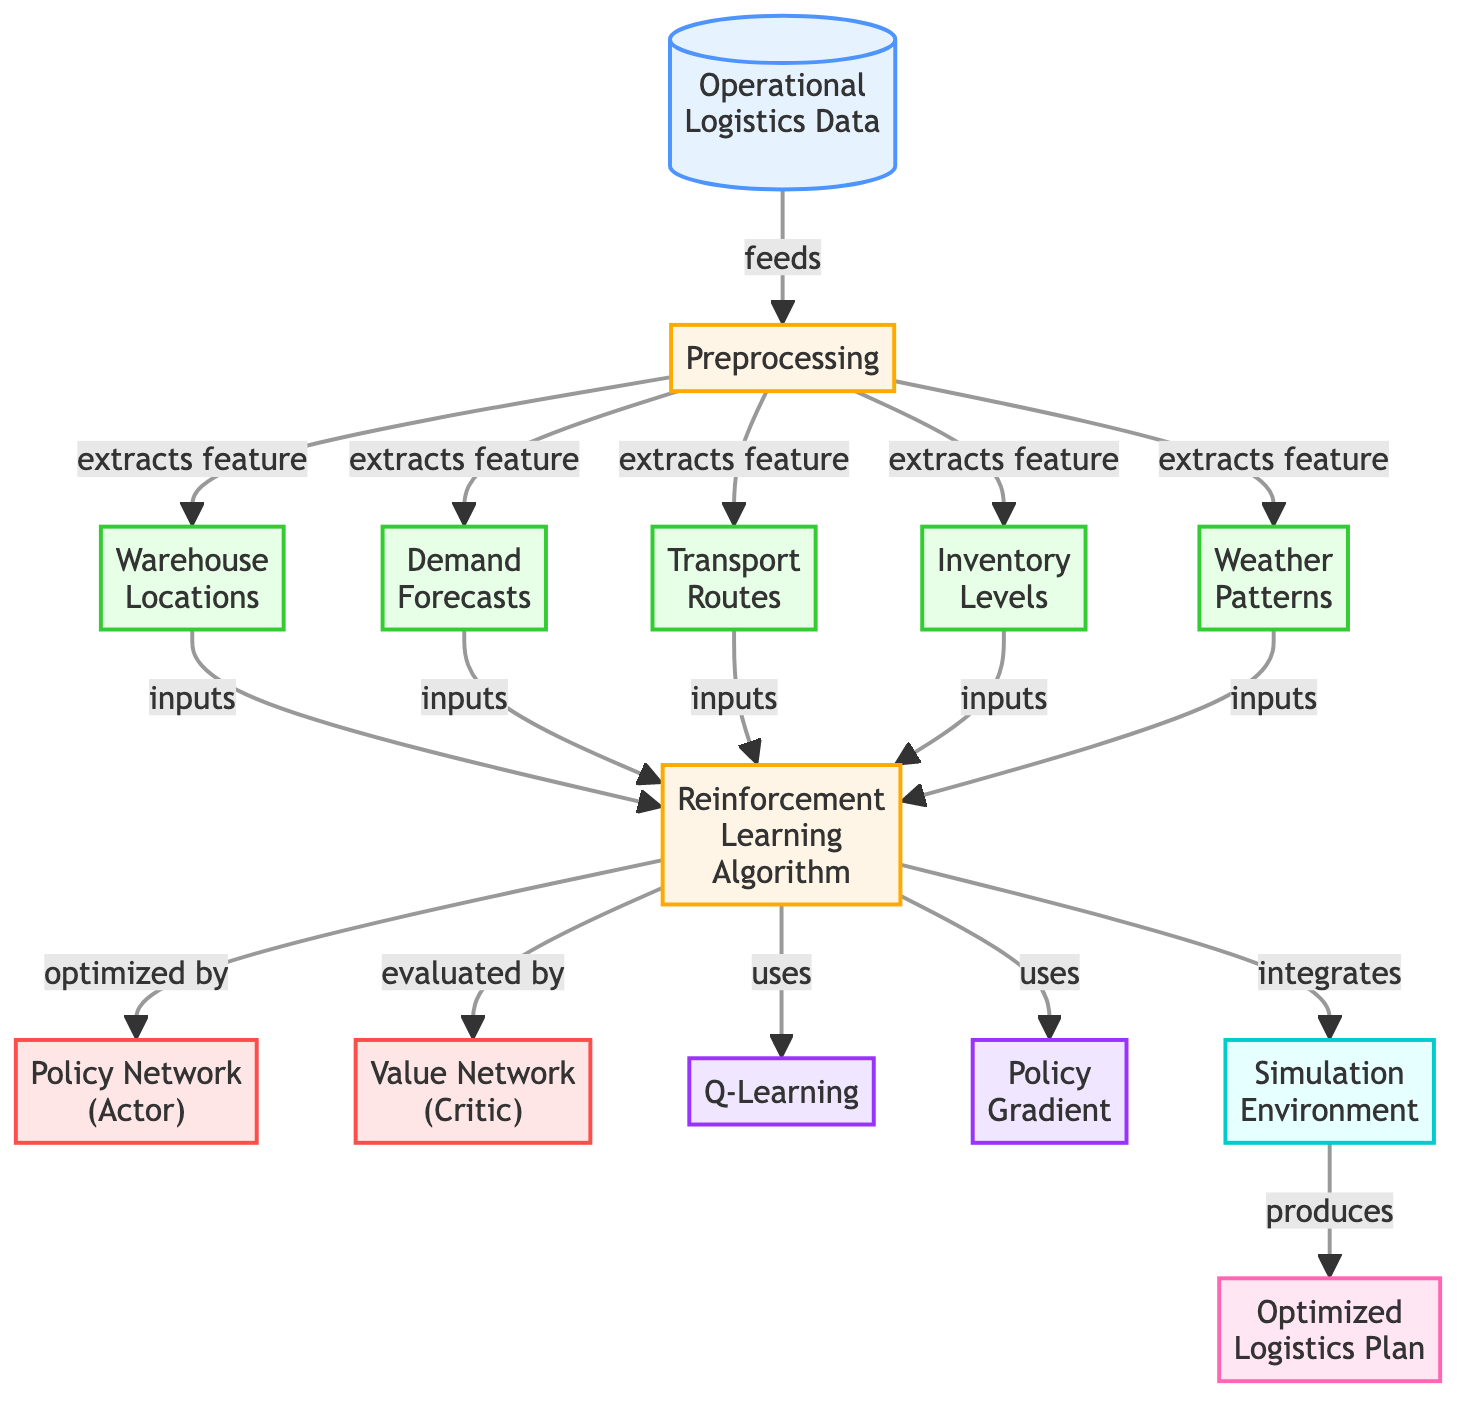What is the initial data source in the diagram? The initial data source represented at the top of the diagram is labeled "Operational Logistics Data." This node is the first in the flow, meaning it starts the entire process.
Answer: Operational Logistics Data How many model components are present in the diagram? By counting the nodes labeled as model components, which are "Policy Network (Actor)" and "Value Network (Critic)," we find there are two such components shown in the diagram.
Answer: 2 What process follows data preprocessing in the flowchart? After the "Preprocessing" step, the next significant block shows the "Reinforcement Learning Algorithm," indicating that this process follows the preprocessing of the operational logistics data.
Answer: Reinforcement Learning Algorithm Which algorithms are used in the reinforcement learning process? The algorithms utilized in the diagram are "Q-Learning" and "Policy Gradient." Both nodes are directly connected to the "Reinforcement Learning Algorithm" node, indicating their use within this part of the process.
Answer: Q-Learning and Policy Gradient What is the result of the simulation environment? The output produced by the "Simulation Environment" node is labeled as "Optimized Logistics Plan." This signifies that once simulations are run, they yield this plan as an outcome.
Answer: Optimized Logistics Plan What is the relationship between the feature nodes and the preprocessing step? The feature nodes, including "Warehouse Locations," "Demand Forecasts," "Transport Routes," "Inventory Levels," and "Weather Patterns," are all connected to the "Preprocessing" step, indicating that the features are extracted from the data during preprocessing.
Answer: Extracted features Which component is evaluated by the reinforcement learning algorithm? The "Value Network (Critic)" is the component that is evaluated by the reinforcement learning process. The diagram shows an arrow indicating that evaluations are made relative to this network.
Answer: Value Network (Critic) What nodes feed into the reinforcement learning algorithm? The nodes feeding into the "Reinforcement Learning Algorithm" include the five feature nodes: "Warehouse Locations," "Demand Forecasts," "Transport Routes," "Inventory Levels," and "Weather Patterns." These nodes collectively provide the necessary inputs.
Answer: Five feature nodes What does the policy network optimize during the reinforcement learning process? The "Policy Network (Actor)" is used to optimize the decisions made by the reinforcement learning algorithm, shaping the logistics strategies based on the rewards evaluated through the critiques given by the value network.
Answer: Decisions made by the algorithm 